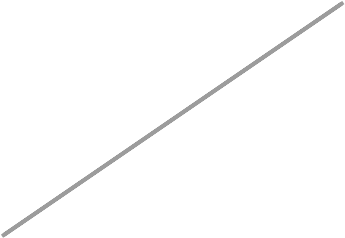<chart> <loc_0><loc_0><loc_500><loc_500><pie_chart><fcel>Ending balance as of December<nl><fcel>100.0%<nl></chart> 